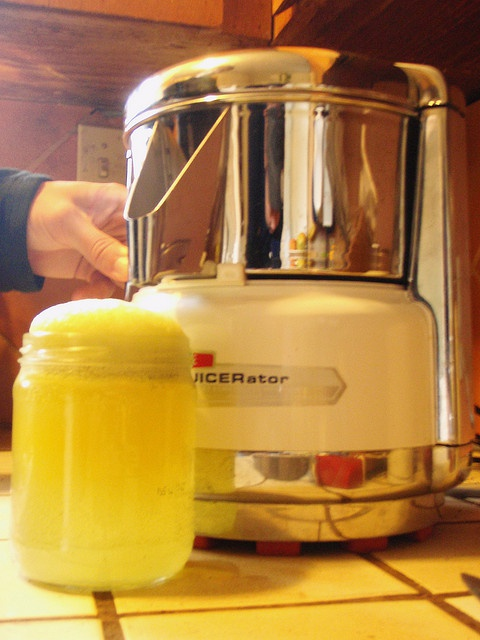Describe the objects in this image and their specific colors. I can see people in gray, tan, and brown tones in this image. 